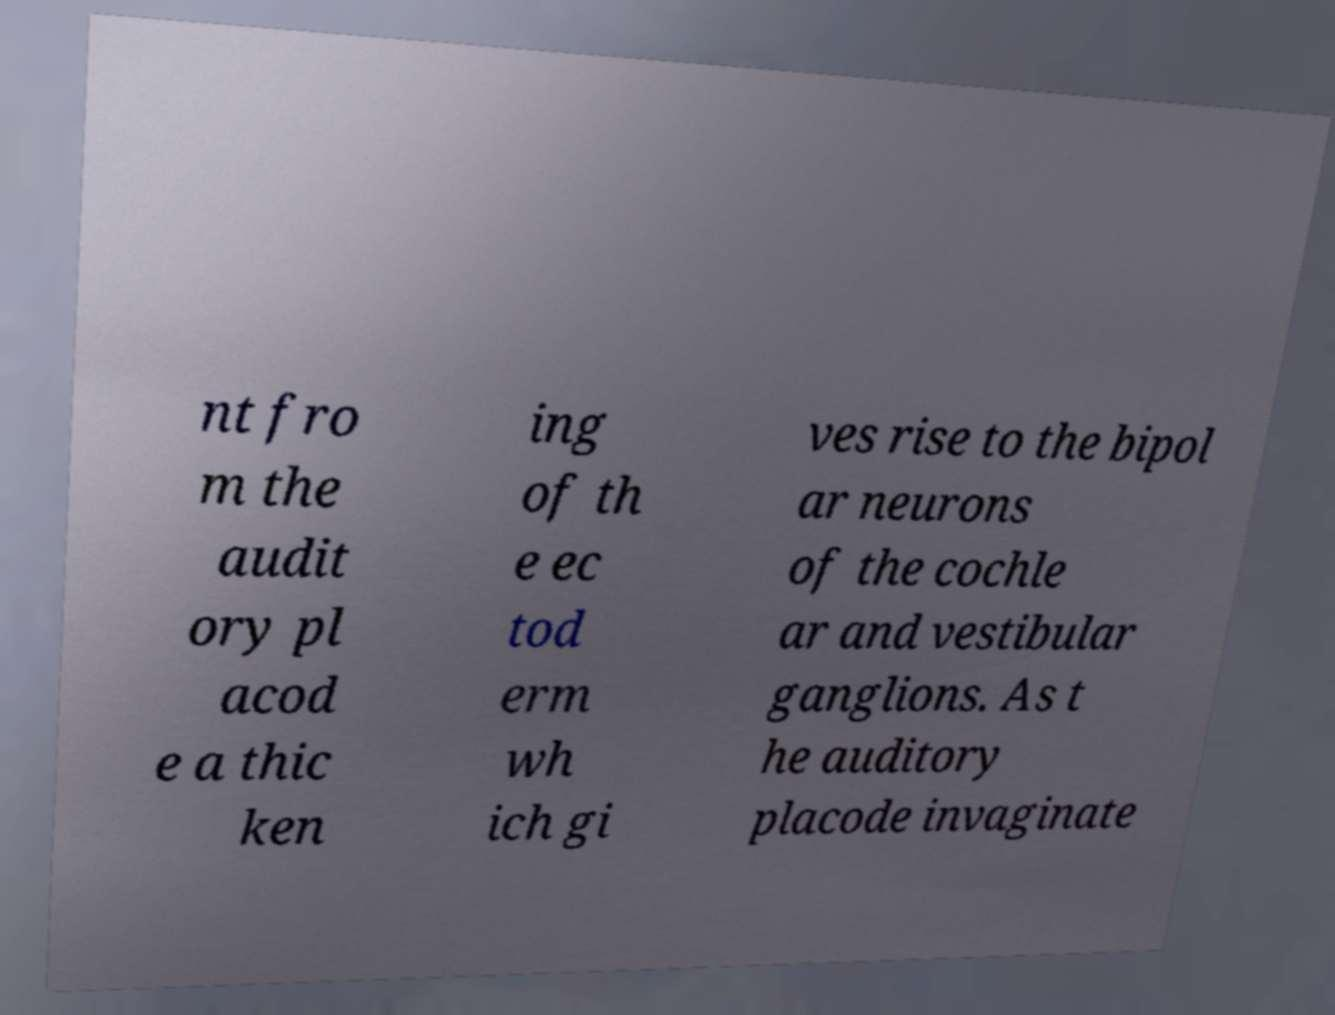Could you assist in decoding the text presented in this image and type it out clearly? nt fro m the audit ory pl acod e a thic ken ing of th e ec tod erm wh ich gi ves rise to the bipol ar neurons of the cochle ar and vestibular ganglions. As t he auditory placode invaginate 